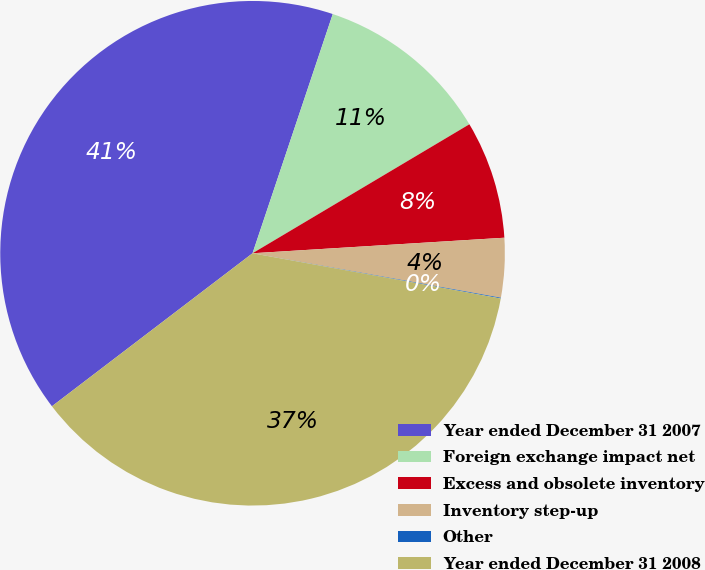<chart> <loc_0><loc_0><loc_500><loc_500><pie_chart><fcel>Year ended December 31 2007<fcel>Foreign exchange impact net<fcel>Excess and obsolete inventory<fcel>Inventory step-up<fcel>Other<fcel>Year ended December 31 2008<nl><fcel>40.52%<fcel>11.31%<fcel>7.56%<fcel>3.8%<fcel>0.05%<fcel>36.76%<nl></chart> 